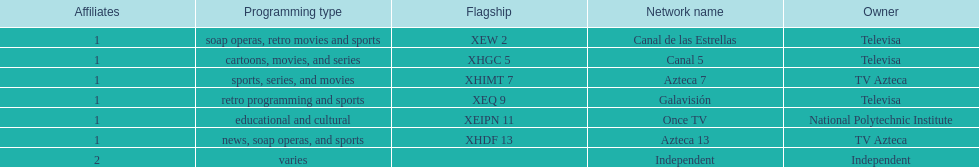Who is the only network owner listed in a consecutive order in the chart? Televisa. 